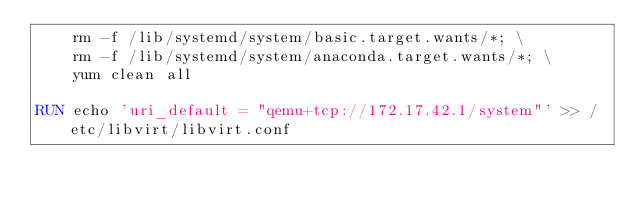Convert code to text. <code><loc_0><loc_0><loc_500><loc_500><_Dockerfile_>    rm -f /lib/systemd/system/basic.target.wants/*; \
    rm -f /lib/systemd/system/anaconda.target.wants/*; \
    yum clean all

RUN echo 'uri_default = "qemu+tcp://172.17.42.1/system"' >> /etc/libvirt/libvirt.conf
</code> 